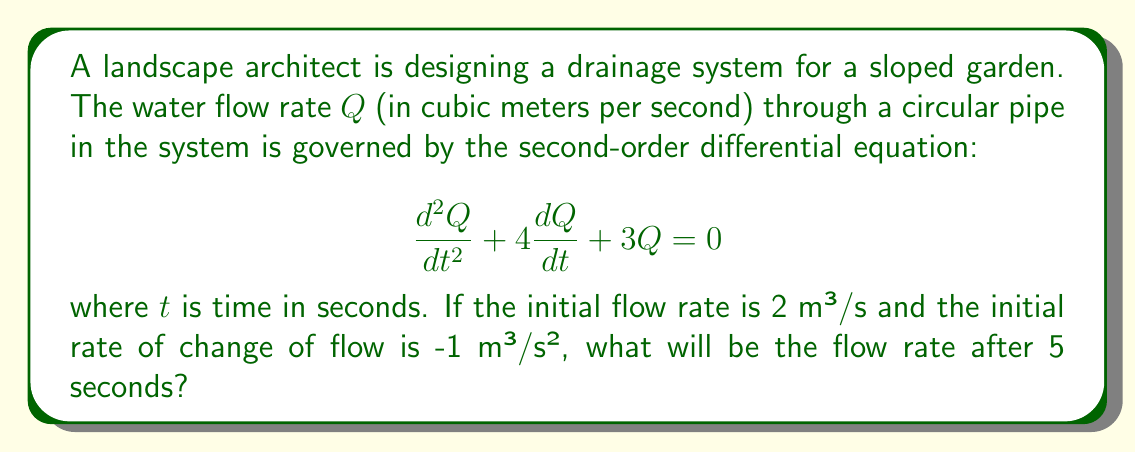Help me with this question. To solve this problem, we need to follow these steps:

1) The given differential equation is a homogeneous second-order linear equation with constant coefficients. Its characteristic equation is:

   $$r^2 + 4r + 3 = 0$$

2) Solving this quadratic equation:
   $$(r + 1)(r + 3) = 0$$
   $$r = -1 \text{ or } r = -3$$

3) Therefore, the general solution is:

   $$Q(t) = c_1e^{-t} + c_2e^{-3t}$$

4) We need to use the initial conditions to find $c_1$ and $c_2$:
   
   At $t = 0$, $Q(0) = 2$ and $Q'(0) = -1$

5) From $Q(0) = 2$:
   
   $$2 = c_1 + c_2$$

6) From $Q'(t) = -c_1e^{-t} - 3c_2e^{-3t}$, we get $Q'(0) = -1$:
   
   $$-1 = -c_1 - 3c_2$$

7) Solving these simultaneous equations:
   
   $$c_1 = \frac{5}{2}, c_2 = -\frac{1}{2}$$

8) Therefore, the particular solution is:

   $$Q(t) = \frac{5}{2}e^{-t} - \frac{1}{2}e^{-3t}$$

9) To find the flow rate after 5 seconds, we substitute $t = 5$:

   $$Q(5) = \frac{5}{2}e^{-5} - \frac{1}{2}e^{-15}$$

10) Calculating this:
    
    $$Q(5) \approx 0.0168 - 0.0000 \approx 0.0168$$
Answer: The flow rate after 5 seconds will be approximately 0.0168 m³/s. 